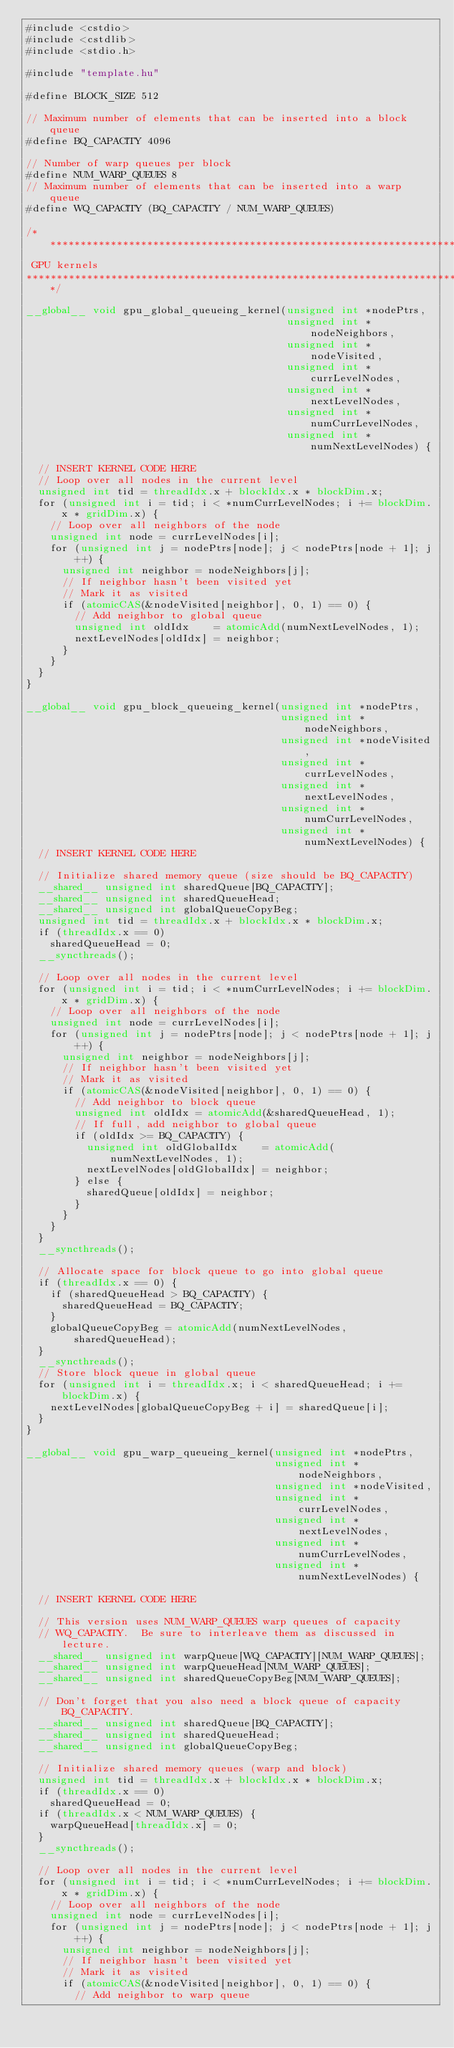Convert code to text. <code><loc_0><loc_0><loc_500><loc_500><_Cuda_>#include <cstdio>
#include <cstdlib>
#include <stdio.h>

#include "template.hu"

#define BLOCK_SIZE 512

// Maximum number of elements that can be inserted into a block queue
#define BQ_CAPACITY 4096

// Number of warp queues per block
#define NUM_WARP_QUEUES 8
// Maximum number of elements that can be inserted into a warp queue
#define WQ_CAPACITY (BQ_CAPACITY / NUM_WARP_QUEUES)

/******************************************************************************
 GPU kernels
*******************************************************************************/

__global__ void gpu_global_queueing_kernel(unsigned int *nodePtrs,
                                           unsigned int *nodeNeighbors,
                                           unsigned int *nodeVisited,
                                           unsigned int *currLevelNodes,
                                           unsigned int *nextLevelNodes,
                                           unsigned int *numCurrLevelNodes,
                                           unsigned int *numNextLevelNodes) {

  // INSERT KERNEL CODE HERE
  // Loop over all nodes in the current level
  unsigned int tid = threadIdx.x + blockIdx.x * blockDim.x;
  for (unsigned int i = tid; i < *numCurrLevelNodes; i += blockDim.x * gridDim.x) {
    // Loop over all neighbors of the node
    unsigned int node = currLevelNodes[i];
    for (unsigned int j = nodePtrs[node]; j < nodePtrs[node + 1]; j++) {
      unsigned int neighbor = nodeNeighbors[j];
      // If neighbor hasn't been visited yet
      // Mark it as visited
      if (atomicCAS(&nodeVisited[neighbor], 0, 1) == 0) {
        // Add neighbor to global queue
        unsigned int oldIdx    = atomicAdd(numNextLevelNodes, 1);
        nextLevelNodes[oldIdx] = neighbor;
      }
    }
  }
}

__global__ void gpu_block_queueing_kernel(unsigned int *nodePtrs,
                                          unsigned int *nodeNeighbors,
                                          unsigned int *nodeVisited,
                                          unsigned int *currLevelNodes,
                                          unsigned int *nextLevelNodes,
                                          unsigned int *numCurrLevelNodes,
                                          unsigned int *numNextLevelNodes) {
  // INSERT KERNEL CODE HERE

  // Initialize shared memory queue (size should be BQ_CAPACITY)
  __shared__ unsigned int sharedQueue[BQ_CAPACITY];
  __shared__ unsigned int sharedQueueHead;
  __shared__ unsigned int globalQueueCopyBeg;
  unsigned int tid = threadIdx.x + blockIdx.x * blockDim.x;
  if (threadIdx.x == 0)
    sharedQueueHead = 0;
  __syncthreads();

  // Loop over all nodes in the current level
  for (unsigned int i = tid; i < *numCurrLevelNodes; i += blockDim.x * gridDim.x) {
    // Loop over all neighbors of the node
    unsigned int node = currLevelNodes[i];
    for (unsigned int j = nodePtrs[node]; j < nodePtrs[node + 1]; j++) {
      unsigned int neighbor = nodeNeighbors[j];
      // If neighbor hasn't been visited yet
      // Mark it as visited
      if (atomicCAS(&nodeVisited[neighbor], 0, 1) == 0) {
        // Add neighbor to block queue
        unsigned int oldIdx = atomicAdd(&sharedQueueHead, 1);
        // If full, add neighbor to global queue
        if (oldIdx >= BQ_CAPACITY) {
          unsigned int oldGlobalIdx    = atomicAdd(numNextLevelNodes, 1);
          nextLevelNodes[oldGlobalIdx] = neighbor;
        } else {
          sharedQueue[oldIdx] = neighbor;
        }
      }
    }
  }
  __syncthreads();

  // Allocate space for block queue to go into global queue
  if (threadIdx.x == 0) {
    if (sharedQueueHead > BQ_CAPACITY) {
      sharedQueueHead = BQ_CAPACITY;
    }
    globalQueueCopyBeg = atomicAdd(numNextLevelNodes, sharedQueueHead);
  }
  __syncthreads();
  // Store block queue in global queue
  for (unsigned int i = threadIdx.x; i < sharedQueueHead; i += blockDim.x) {
    nextLevelNodes[globalQueueCopyBeg + i] = sharedQueue[i];
  }
}

__global__ void gpu_warp_queueing_kernel(unsigned int *nodePtrs,
                                         unsigned int *nodeNeighbors,
                                         unsigned int *nodeVisited,
                                         unsigned int *currLevelNodes,
                                         unsigned int *nextLevelNodes,
                                         unsigned int *numCurrLevelNodes,
                                         unsigned int *numNextLevelNodes) {

  // INSERT KERNEL CODE HERE

  // This version uses NUM_WARP_QUEUES warp queues of capacity
  // WQ_CAPACITY.  Be sure to interleave them as discussed in lecture.
  __shared__ unsigned int warpQueue[WQ_CAPACITY][NUM_WARP_QUEUES];
  __shared__ unsigned int warpQueueHead[NUM_WARP_QUEUES];
  __shared__ unsigned int sharedQueueCopyBeg[NUM_WARP_QUEUES];

  // Don't forget that you also need a block queue of capacity BQ_CAPACITY.
  __shared__ unsigned int sharedQueue[BQ_CAPACITY];
  __shared__ unsigned int sharedQueueHead;
  __shared__ unsigned int globalQueueCopyBeg;

  // Initialize shared memory queues (warp and block)
  unsigned int tid = threadIdx.x + blockIdx.x * blockDim.x;
  if (threadIdx.x == 0)
    sharedQueueHead = 0;
  if (threadIdx.x < NUM_WARP_QUEUES) {
    warpQueueHead[threadIdx.x] = 0;
  }
  __syncthreads();

  // Loop over all nodes in the current level
  for (unsigned int i = tid; i < *numCurrLevelNodes; i += blockDim.x * gridDim.x) {
    // Loop over all neighbors of the node
    unsigned int node = currLevelNodes[i];
    for (unsigned int j = nodePtrs[node]; j < nodePtrs[node + 1]; j++) {
      unsigned int neighbor = nodeNeighbors[j];
      // If neighbor hasn't been visited yet
      // Mark it as visited
      if (atomicCAS(&nodeVisited[neighbor], 0, 1) == 0) {
        // Add neighbor to warp queue</code> 